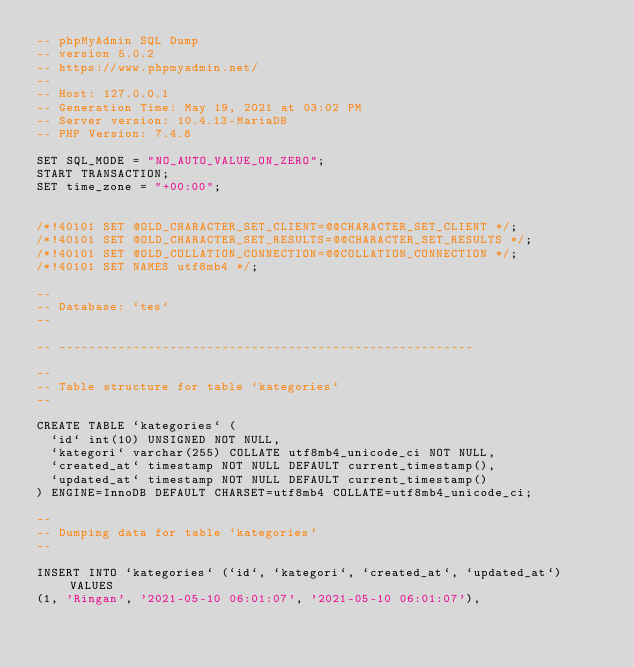Convert code to text. <code><loc_0><loc_0><loc_500><loc_500><_SQL_>-- phpMyAdmin SQL Dump
-- version 5.0.2
-- https://www.phpmyadmin.net/
--
-- Host: 127.0.0.1
-- Generation Time: May 19, 2021 at 03:02 PM
-- Server version: 10.4.13-MariaDB
-- PHP Version: 7.4.8

SET SQL_MODE = "NO_AUTO_VALUE_ON_ZERO";
START TRANSACTION;
SET time_zone = "+00:00";


/*!40101 SET @OLD_CHARACTER_SET_CLIENT=@@CHARACTER_SET_CLIENT */;
/*!40101 SET @OLD_CHARACTER_SET_RESULTS=@@CHARACTER_SET_RESULTS */;
/*!40101 SET @OLD_COLLATION_CONNECTION=@@COLLATION_CONNECTION */;
/*!40101 SET NAMES utf8mb4 */;

--
-- Database: `tes`
--

-- --------------------------------------------------------

--
-- Table structure for table `kategories`
--

CREATE TABLE `kategories` (
  `id` int(10) UNSIGNED NOT NULL,
  `kategori` varchar(255) COLLATE utf8mb4_unicode_ci NOT NULL,
  `created_at` timestamp NOT NULL DEFAULT current_timestamp(),
  `updated_at` timestamp NOT NULL DEFAULT current_timestamp()
) ENGINE=InnoDB DEFAULT CHARSET=utf8mb4 COLLATE=utf8mb4_unicode_ci;

--
-- Dumping data for table `kategories`
--

INSERT INTO `kategories` (`id`, `kategori`, `created_at`, `updated_at`) VALUES
(1, 'Ringan', '2021-05-10 06:01:07', '2021-05-10 06:01:07'),</code> 